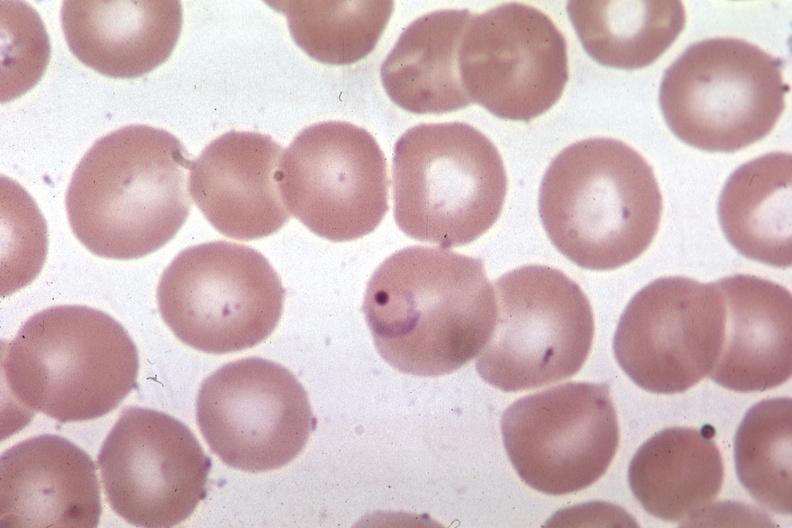does this image show ring form?
Answer the question using a single word or phrase. Yes 